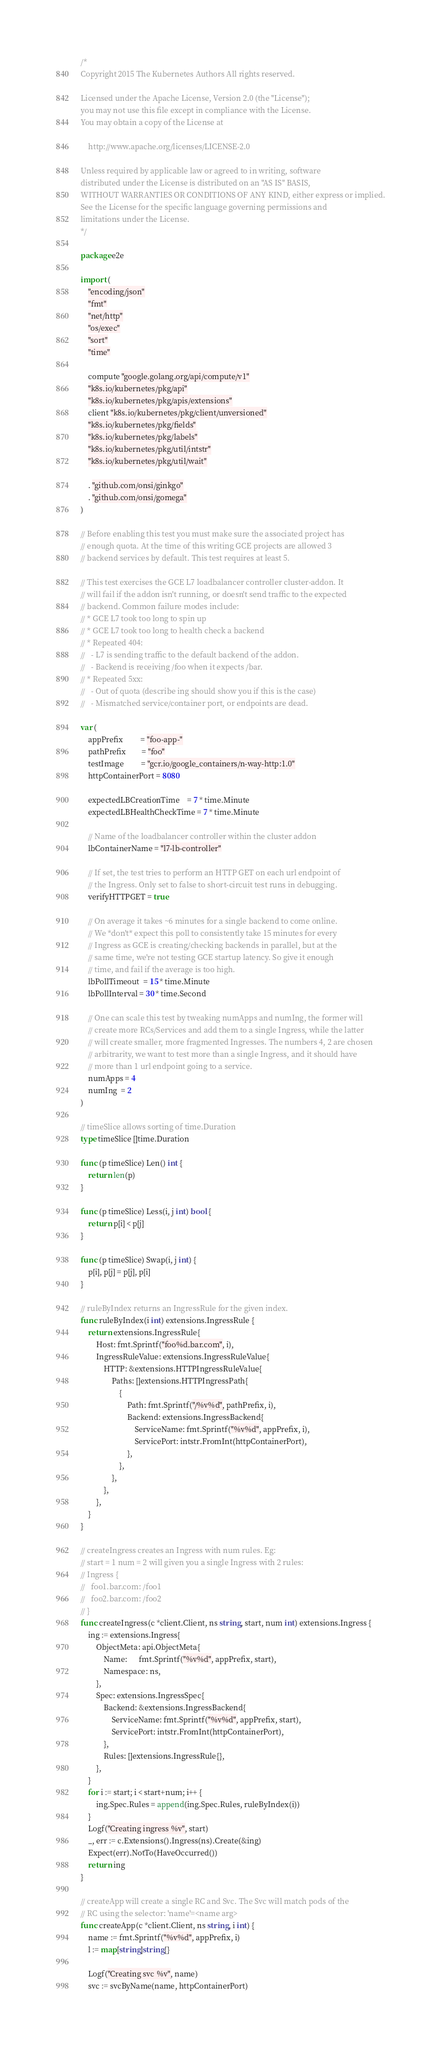Convert code to text. <code><loc_0><loc_0><loc_500><loc_500><_Go_>/*
Copyright 2015 The Kubernetes Authors All rights reserved.

Licensed under the Apache License, Version 2.0 (the "License");
you may not use this file except in compliance with the License.
You may obtain a copy of the License at

    http://www.apache.org/licenses/LICENSE-2.0

Unless required by applicable law or agreed to in writing, software
distributed under the License is distributed on an "AS IS" BASIS,
WITHOUT WARRANTIES OR CONDITIONS OF ANY KIND, either express or implied.
See the License for the specific language governing permissions and
limitations under the License.
*/

package e2e

import (
	"encoding/json"
	"fmt"
	"net/http"
	"os/exec"
	"sort"
	"time"

	compute "google.golang.org/api/compute/v1"
	"k8s.io/kubernetes/pkg/api"
	"k8s.io/kubernetes/pkg/apis/extensions"
	client "k8s.io/kubernetes/pkg/client/unversioned"
	"k8s.io/kubernetes/pkg/fields"
	"k8s.io/kubernetes/pkg/labels"
	"k8s.io/kubernetes/pkg/util/intstr"
	"k8s.io/kubernetes/pkg/util/wait"

	. "github.com/onsi/ginkgo"
	. "github.com/onsi/gomega"
)

// Before enabling this test you must make sure the associated project has
// enough quota. At the time of this writing GCE projects are allowed 3
// backend services by default. This test requires at least 5.

// This test exercises the GCE L7 loadbalancer controller cluster-addon. It
// will fail if the addon isn't running, or doesn't send traffic to the expected
// backend. Common failure modes include:
// * GCE L7 took too long to spin up
// * GCE L7 took too long to health check a backend
// * Repeated 404:
//   - L7 is sending traffic to the default backend of the addon.
//   - Backend is receiving /foo when it expects /bar.
// * Repeated 5xx:
//   - Out of quota (describe ing should show you if this is the case)
//   - Mismatched service/container port, or endpoints are dead.

var (
	appPrefix         = "foo-app-"
	pathPrefix        = "foo"
	testImage         = "gcr.io/google_containers/n-way-http:1.0"
	httpContainerPort = 8080

	expectedLBCreationTime    = 7 * time.Minute
	expectedLBHealthCheckTime = 7 * time.Minute

	// Name of the loadbalancer controller within the cluster addon
	lbContainerName = "l7-lb-controller"

	// If set, the test tries to perform an HTTP GET on each url endpoint of
	// the Ingress. Only set to false to short-circuit test runs in debugging.
	verifyHTTPGET = true

	// On average it takes ~6 minutes for a single backend to come online.
	// We *don't* expect this poll to consistently take 15 minutes for every
	// Ingress as GCE is creating/checking backends in parallel, but at the
	// same time, we're not testing GCE startup latency. So give it enough
	// time, and fail if the average is too high.
	lbPollTimeout  = 15 * time.Minute
	lbPollInterval = 30 * time.Second

	// One can scale this test by tweaking numApps and numIng, the former will
	// create more RCs/Services and add them to a single Ingress, while the latter
	// will create smaller, more fragmented Ingresses. The numbers 4, 2 are chosen
	// arbitrarity, we want to test more than a single Ingress, and it should have
	// more than 1 url endpoint going to a service.
	numApps = 4
	numIng  = 2
)

// timeSlice allows sorting of time.Duration
type timeSlice []time.Duration

func (p timeSlice) Len() int {
	return len(p)
}

func (p timeSlice) Less(i, j int) bool {
	return p[i] < p[j]
}

func (p timeSlice) Swap(i, j int) {
	p[i], p[j] = p[j], p[i]
}

// ruleByIndex returns an IngressRule for the given index.
func ruleByIndex(i int) extensions.IngressRule {
	return extensions.IngressRule{
		Host: fmt.Sprintf("foo%d.bar.com", i),
		IngressRuleValue: extensions.IngressRuleValue{
			HTTP: &extensions.HTTPIngressRuleValue{
				Paths: []extensions.HTTPIngressPath{
					{
						Path: fmt.Sprintf("/%v%d", pathPrefix, i),
						Backend: extensions.IngressBackend{
							ServiceName: fmt.Sprintf("%v%d", appPrefix, i),
							ServicePort: intstr.FromInt(httpContainerPort),
						},
					},
				},
			},
		},
	}
}

// createIngress creates an Ingress with num rules. Eg:
// start = 1 num = 2 will given you a single Ingress with 2 rules:
// Ingress {
//	 foo1.bar.com: /foo1
//	 foo2.bar.com: /foo2
// }
func createIngress(c *client.Client, ns string, start, num int) extensions.Ingress {
	ing := extensions.Ingress{
		ObjectMeta: api.ObjectMeta{
			Name:      fmt.Sprintf("%v%d", appPrefix, start),
			Namespace: ns,
		},
		Spec: extensions.IngressSpec{
			Backend: &extensions.IngressBackend{
				ServiceName: fmt.Sprintf("%v%d", appPrefix, start),
				ServicePort: intstr.FromInt(httpContainerPort),
			},
			Rules: []extensions.IngressRule{},
		},
	}
	for i := start; i < start+num; i++ {
		ing.Spec.Rules = append(ing.Spec.Rules, ruleByIndex(i))
	}
	Logf("Creating ingress %v", start)
	_, err := c.Extensions().Ingress(ns).Create(&ing)
	Expect(err).NotTo(HaveOccurred())
	return ing
}

// createApp will create a single RC and Svc. The Svc will match pods of the
// RC using the selector: 'name'=<name arg>
func createApp(c *client.Client, ns string, i int) {
	name := fmt.Sprintf("%v%d", appPrefix, i)
	l := map[string]string{}

	Logf("Creating svc %v", name)
	svc := svcByName(name, httpContainerPort)</code> 